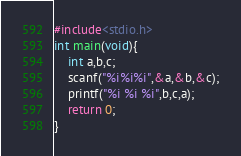<code> <loc_0><loc_0><loc_500><loc_500><_C_>#include<stdio.h>
int main(void){
    int a,b,c;
    scanf("%i%i%i",&a,&b,&c);
    printf("%i %i %i",b,c,a);
    return 0;
}</code> 